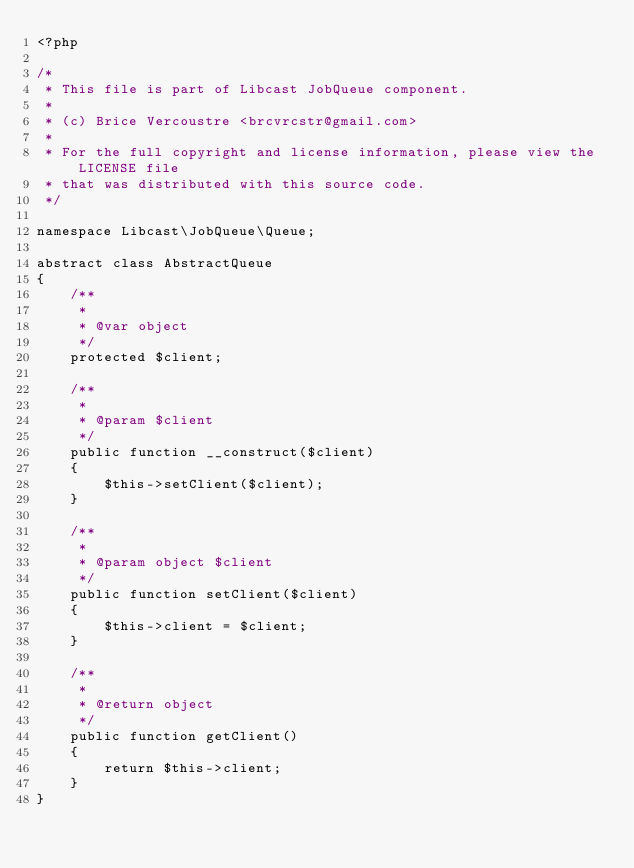<code> <loc_0><loc_0><loc_500><loc_500><_PHP_><?php

/*
 * This file is part of Libcast JobQueue component.
 *
 * (c) Brice Vercoustre <brcvrcstr@gmail.com>
 *
 * For the full copyright and license information, please view the LICENSE file
 * that was distributed with this source code.
 */

namespace Libcast\JobQueue\Queue;

abstract class AbstractQueue
{
    /**
     *
     * @var object
     */
    protected $client;

    /**
     *
     * @param $client
     */
    public function __construct($client)
    {
        $this->setClient($client);
    }

    /**
     *
     * @param object $client
     */
    public function setClient($client)
    {
        $this->client = $client;
    }

    /**
     *
     * @return object
     */
    public function getClient()
    {
        return $this->client;
    }
}
</code> 